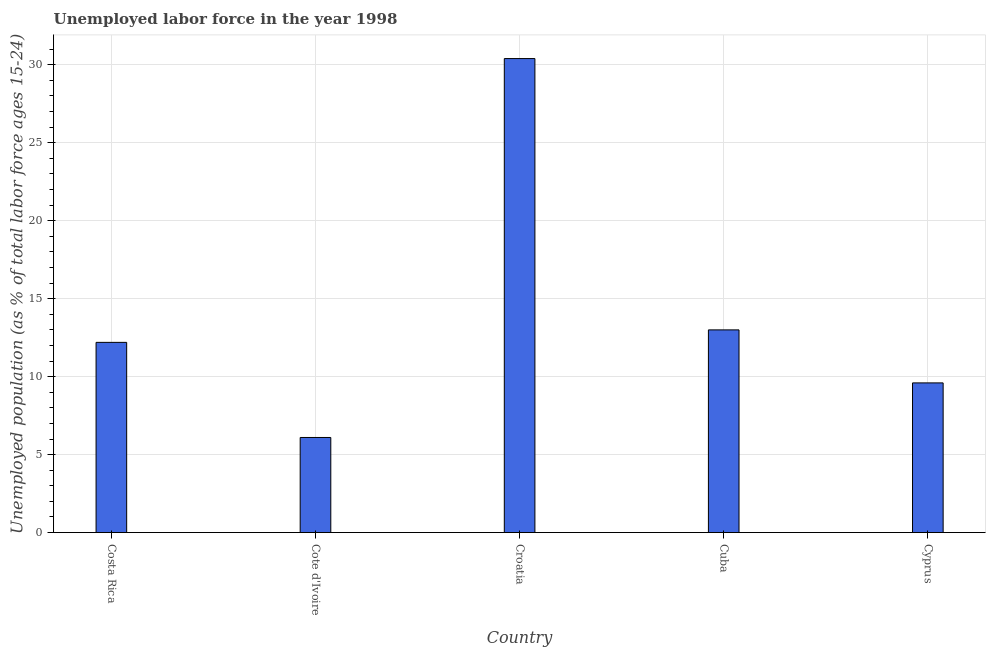What is the title of the graph?
Offer a very short reply. Unemployed labor force in the year 1998. What is the label or title of the X-axis?
Provide a succinct answer. Country. What is the label or title of the Y-axis?
Give a very brief answer. Unemployed population (as % of total labor force ages 15-24). What is the total unemployed youth population in Costa Rica?
Provide a short and direct response. 12.2. Across all countries, what is the maximum total unemployed youth population?
Your answer should be very brief. 30.4. Across all countries, what is the minimum total unemployed youth population?
Offer a terse response. 6.1. In which country was the total unemployed youth population maximum?
Your answer should be compact. Croatia. In which country was the total unemployed youth population minimum?
Ensure brevity in your answer.  Cote d'Ivoire. What is the sum of the total unemployed youth population?
Provide a short and direct response. 71.3. What is the difference between the total unemployed youth population in Cote d'Ivoire and Cuba?
Keep it short and to the point. -6.9. What is the average total unemployed youth population per country?
Your answer should be very brief. 14.26. What is the median total unemployed youth population?
Give a very brief answer. 12.2. In how many countries, is the total unemployed youth population greater than 24 %?
Your answer should be compact. 1. What is the difference between the highest and the second highest total unemployed youth population?
Provide a short and direct response. 17.4. What is the difference between the highest and the lowest total unemployed youth population?
Your answer should be very brief. 24.3. How many bars are there?
Keep it short and to the point. 5. How many countries are there in the graph?
Make the answer very short. 5. What is the difference between two consecutive major ticks on the Y-axis?
Offer a terse response. 5. Are the values on the major ticks of Y-axis written in scientific E-notation?
Give a very brief answer. No. What is the Unemployed population (as % of total labor force ages 15-24) of Costa Rica?
Offer a terse response. 12.2. What is the Unemployed population (as % of total labor force ages 15-24) of Cote d'Ivoire?
Offer a very short reply. 6.1. What is the Unemployed population (as % of total labor force ages 15-24) in Croatia?
Your answer should be compact. 30.4. What is the Unemployed population (as % of total labor force ages 15-24) of Cuba?
Give a very brief answer. 13. What is the Unemployed population (as % of total labor force ages 15-24) in Cyprus?
Offer a terse response. 9.6. What is the difference between the Unemployed population (as % of total labor force ages 15-24) in Costa Rica and Cote d'Ivoire?
Make the answer very short. 6.1. What is the difference between the Unemployed population (as % of total labor force ages 15-24) in Costa Rica and Croatia?
Offer a very short reply. -18.2. What is the difference between the Unemployed population (as % of total labor force ages 15-24) in Costa Rica and Cuba?
Offer a terse response. -0.8. What is the difference between the Unemployed population (as % of total labor force ages 15-24) in Costa Rica and Cyprus?
Offer a terse response. 2.6. What is the difference between the Unemployed population (as % of total labor force ages 15-24) in Cote d'Ivoire and Croatia?
Ensure brevity in your answer.  -24.3. What is the difference between the Unemployed population (as % of total labor force ages 15-24) in Cote d'Ivoire and Cyprus?
Make the answer very short. -3.5. What is the difference between the Unemployed population (as % of total labor force ages 15-24) in Croatia and Cuba?
Your response must be concise. 17.4. What is the difference between the Unemployed population (as % of total labor force ages 15-24) in Croatia and Cyprus?
Provide a short and direct response. 20.8. What is the ratio of the Unemployed population (as % of total labor force ages 15-24) in Costa Rica to that in Croatia?
Your answer should be very brief. 0.4. What is the ratio of the Unemployed population (as % of total labor force ages 15-24) in Costa Rica to that in Cuba?
Keep it short and to the point. 0.94. What is the ratio of the Unemployed population (as % of total labor force ages 15-24) in Costa Rica to that in Cyprus?
Offer a terse response. 1.27. What is the ratio of the Unemployed population (as % of total labor force ages 15-24) in Cote d'Ivoire to that in Croatia?
Provide a succinct answer. 0.2. What is the ratio of the Unemployed population (as % of total labor force ages 15-24) in Cote d'Ivoire to that in Cuba?
Your answer should be very brief. 0.47. What is the ratio of the Unemployed population (as % of total labor force ages 15-24) in Cote d'Ivoire to that in Cyprus?
Keep it short and to the point. 0.64. What is the ratio of the Unemployed population (as % of total labor force ages 15-24) in Croatia to that in Cuba?
Your answer should be compact. 2.34. What is the ratio of the Unemployed population (as % of total labor force ages 15-24) in Croatia to that in Cyprus?
Your response must be concise. 3.17. What is the ratio of the Unemployed population (as % of total labor force ages 15-24) in Cuba to that in Cyprus?
Your answer should be compact. 1.35. 